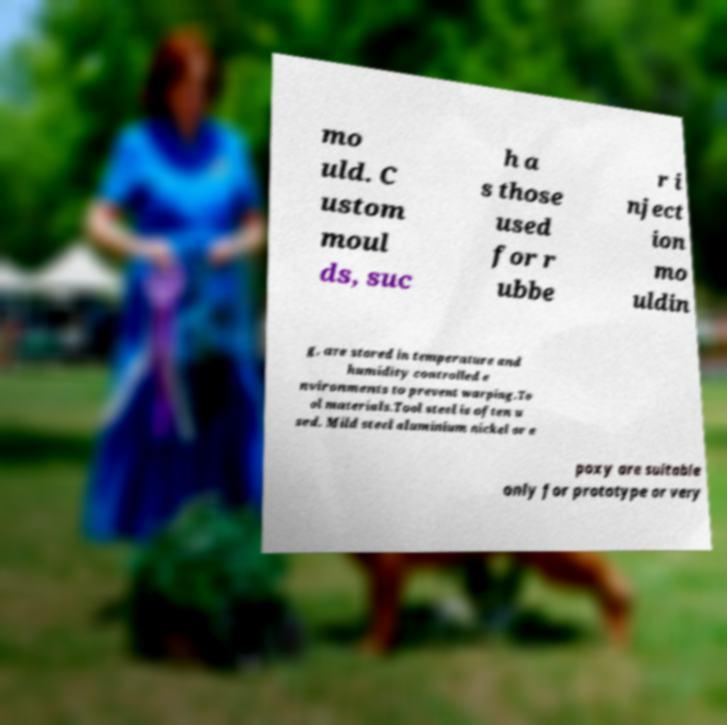Please read and relay the text visible in this image. What does it say? mo uld. C ustom moul ds, suc h a s those used for r ubbe r i nject ion mo uldin g, are stored in temperature and humidity controlled e nvironments to prevent warping.To ol materials.Tool steel is often u sed. Mild steel aluminium nickel or e poxy are suitable only for prototype or very 